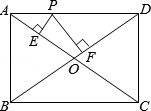In a different scenario, if point P was exactly at the midpoint of AD, what would be the lengths of PE and PF? If point P is at the midpoint of AD, then AP = PD and triangle APD is a right triangle with sides of length 3 and 4 and a hypotenuse of 5. Since the diagonals of a rectangle are equal, AO and DO are also 2.5 each. With P at the midpoint, PE and PF would be equal due to symmetry and each would be half the length of OD or OA which is 2.5. So PE = PF = 2.5 units. 